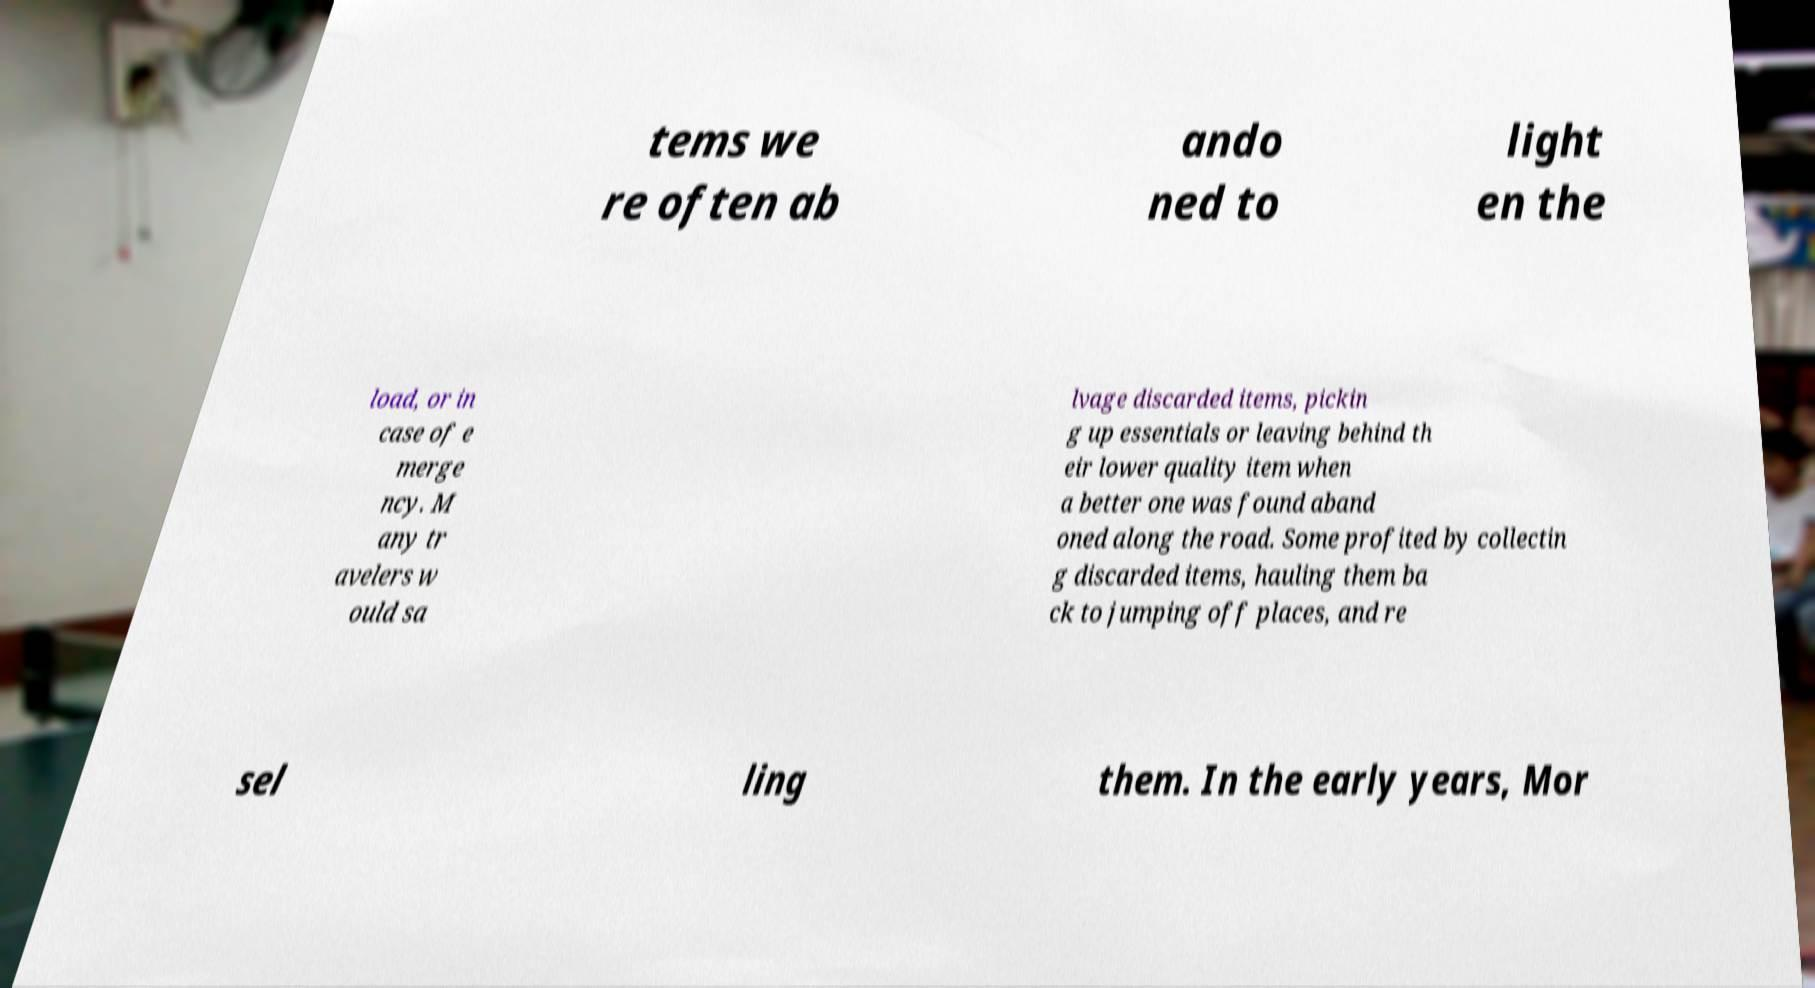Could you assist in decoding the text presented in this image and type it out clearly? tems we re often ab ando ned to light en the load, or in case of e merge ncy. M any tr avelers w ould sa lvage discarded items, pickin g up essentials or leaving behind th eir lower quality item when a better one was found aband oned along the road. Some profited by collectin g discarded items, hauling them ba ck to jumping off places, and re sel ling them. In the early years, Mor 